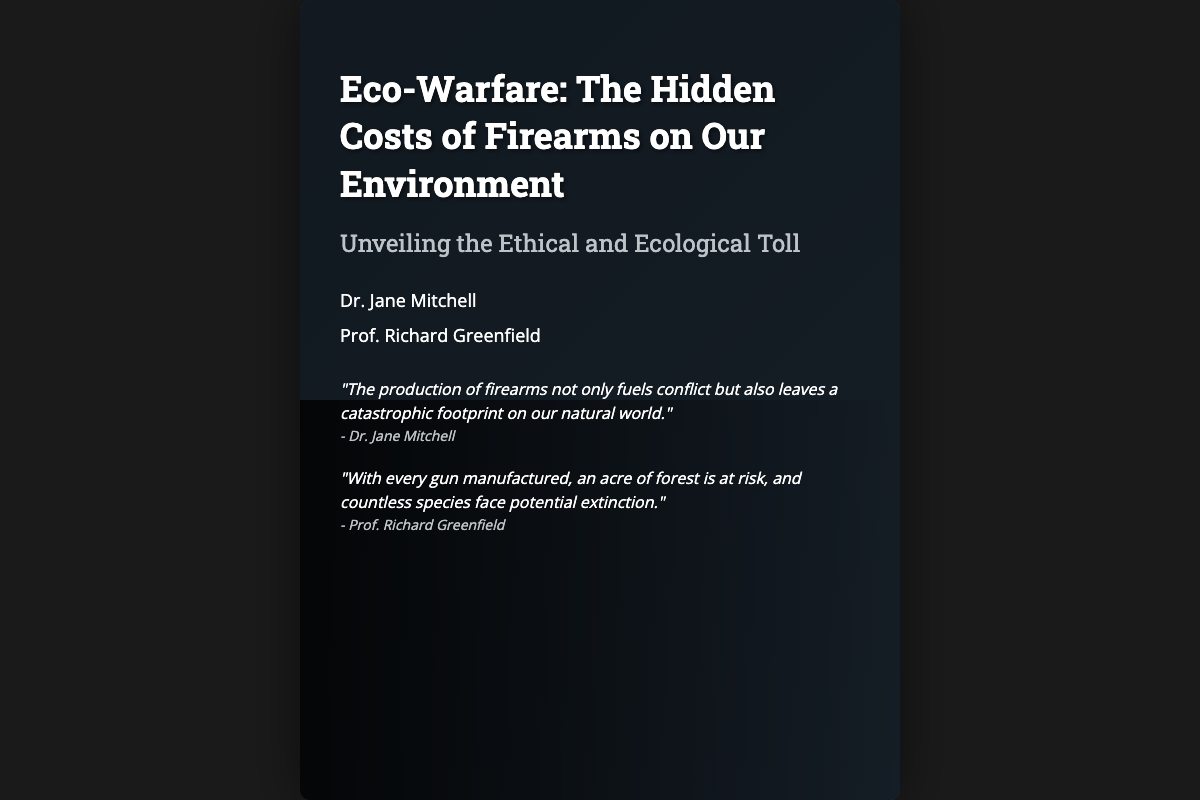What is the title of the book? The title is prominently displayed on the cover.
Answer: Eco-Warfare: The Hidden Costs of Firearms on Our Environment Who are the authors of the book? The authors' names are listed just below the title.
Answer: Dr. Jane Mitchell and Prof. Richard Greenfield What is the subtitle of the book? The subtitle is included under the title to provide more context.
Answer: Unveiling the Ethical and Ecological Toll What does the factory in the cover represent? The factory is centrally placed and emphasizes the industrial impact on the environment.
Answer: Industrial impact What is being endangered according to the quotes? The quotes explicitly mention threats to natural elements due to firearms production.
Answer: Countless species What ethical issue is highlighted in the quotes? The quotes elaborate on the moral considerations related to firearms production.
Answer: Catastrophic footprint What visual elements are juxtaposed in the cover design? The cover features contrasting imagery to depict different themes.
Answer: Factory and wildlife What is the main environmental theme depicted in the cover? The overall visuals and quotes suggest a strong focus on ecological degradation.
Answer: Ecological toll How much of nature is at risk with every gun manufactured? The quote suggests a specific environmental metric indicating risk.
Answer: One acre of forest 